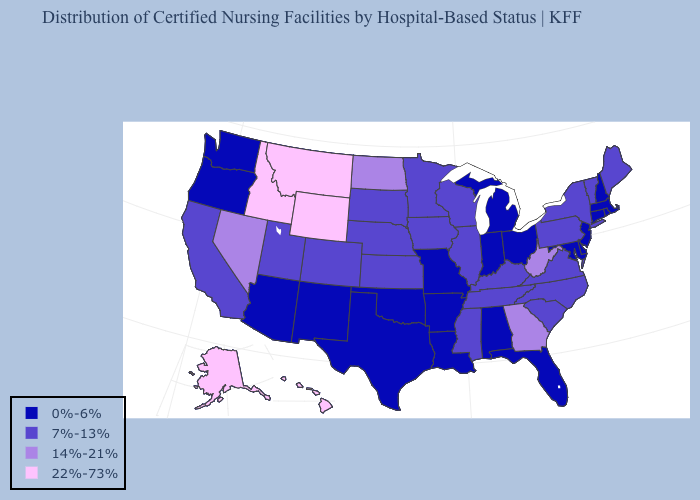Name the states that have a value in the range 7%-13%?
Write a very short answer. California, Colorado, Illinois, Iowa, Kansas, Kentucky, Maine, Minnesota, Mississippi, Nebraska, New York, North Carolina, Pennsylvania, South Carolina, South Dakota, Tennessee, Utah, Vermont, Virginia, Wisconsin. What is the highest value in the West ?
Write a very short answer. 22%-73%. Does Oregon have the same value as Texas?
Write a very short answer. Yes. What is the value of Missouri?
Keep it brief. 0%-6%. Which states have the lowest value in the Northeast?
Be succinct. Connecticut, Massachusetts, New Hampshire, New Jersey, Rhode Island. Does Massachusetts have the lowest value in the Northeast?
Concise answer only. Yes. What is the value of Michigan?
Quick response, please. 0%-6%. What is the value of Connecticut?
Concise answer only. 0%-6%. Name the states that have a value in the range 0%-6%?
Give a very brief answer. Alabama, Arizona, Arkansas, Connecticut, Delaware, Florida, Indiana, Louisiana, Maryland, Massachusetts, Michigan, Missouri, New Hampshire, New Jersey, New Mexico, Ohio, Oklahoma, Oregon, Rhode Island, Texas, Washington. Does Virginia have a higher value than North Carolina?
Quick response, please. No. What is the lowest value in the USA?
Short answer required. 0%-6%. What is the value of New Hampshire?
Write a very short answer. 0%-6%. Name the states that have a value in the range 0%-6%?
Answer briefly. Alabama, Arizona, Arkansas, Connecticut, Delaware, Florida, Indiana, Louisiana, Maryland, Massachusetts, Michigan, Missouri, New Hampshire, New Jersey, New Mexico, Ohio, Oklahoma, Oregon, Rhode Island, Texas, Washington. Which states have the lowest value in the Northeast?
Keep it brief. Connecticut, Massachusetts, New Hampshire, New Jersey, Rhode Island. What is the value of West Virginia?
Give a very brief answer. 14%-21%. 